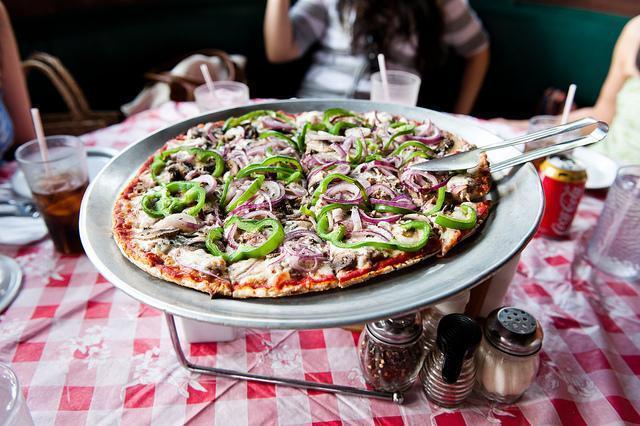How many straws in the picture?
Give a very brief answer. 4. How many cups are in the picture?
Give a very brief answer. 3. How many knives can you see?
Give a very brief answer. 1. How many people are there?
Give a very brief answer. 3. 